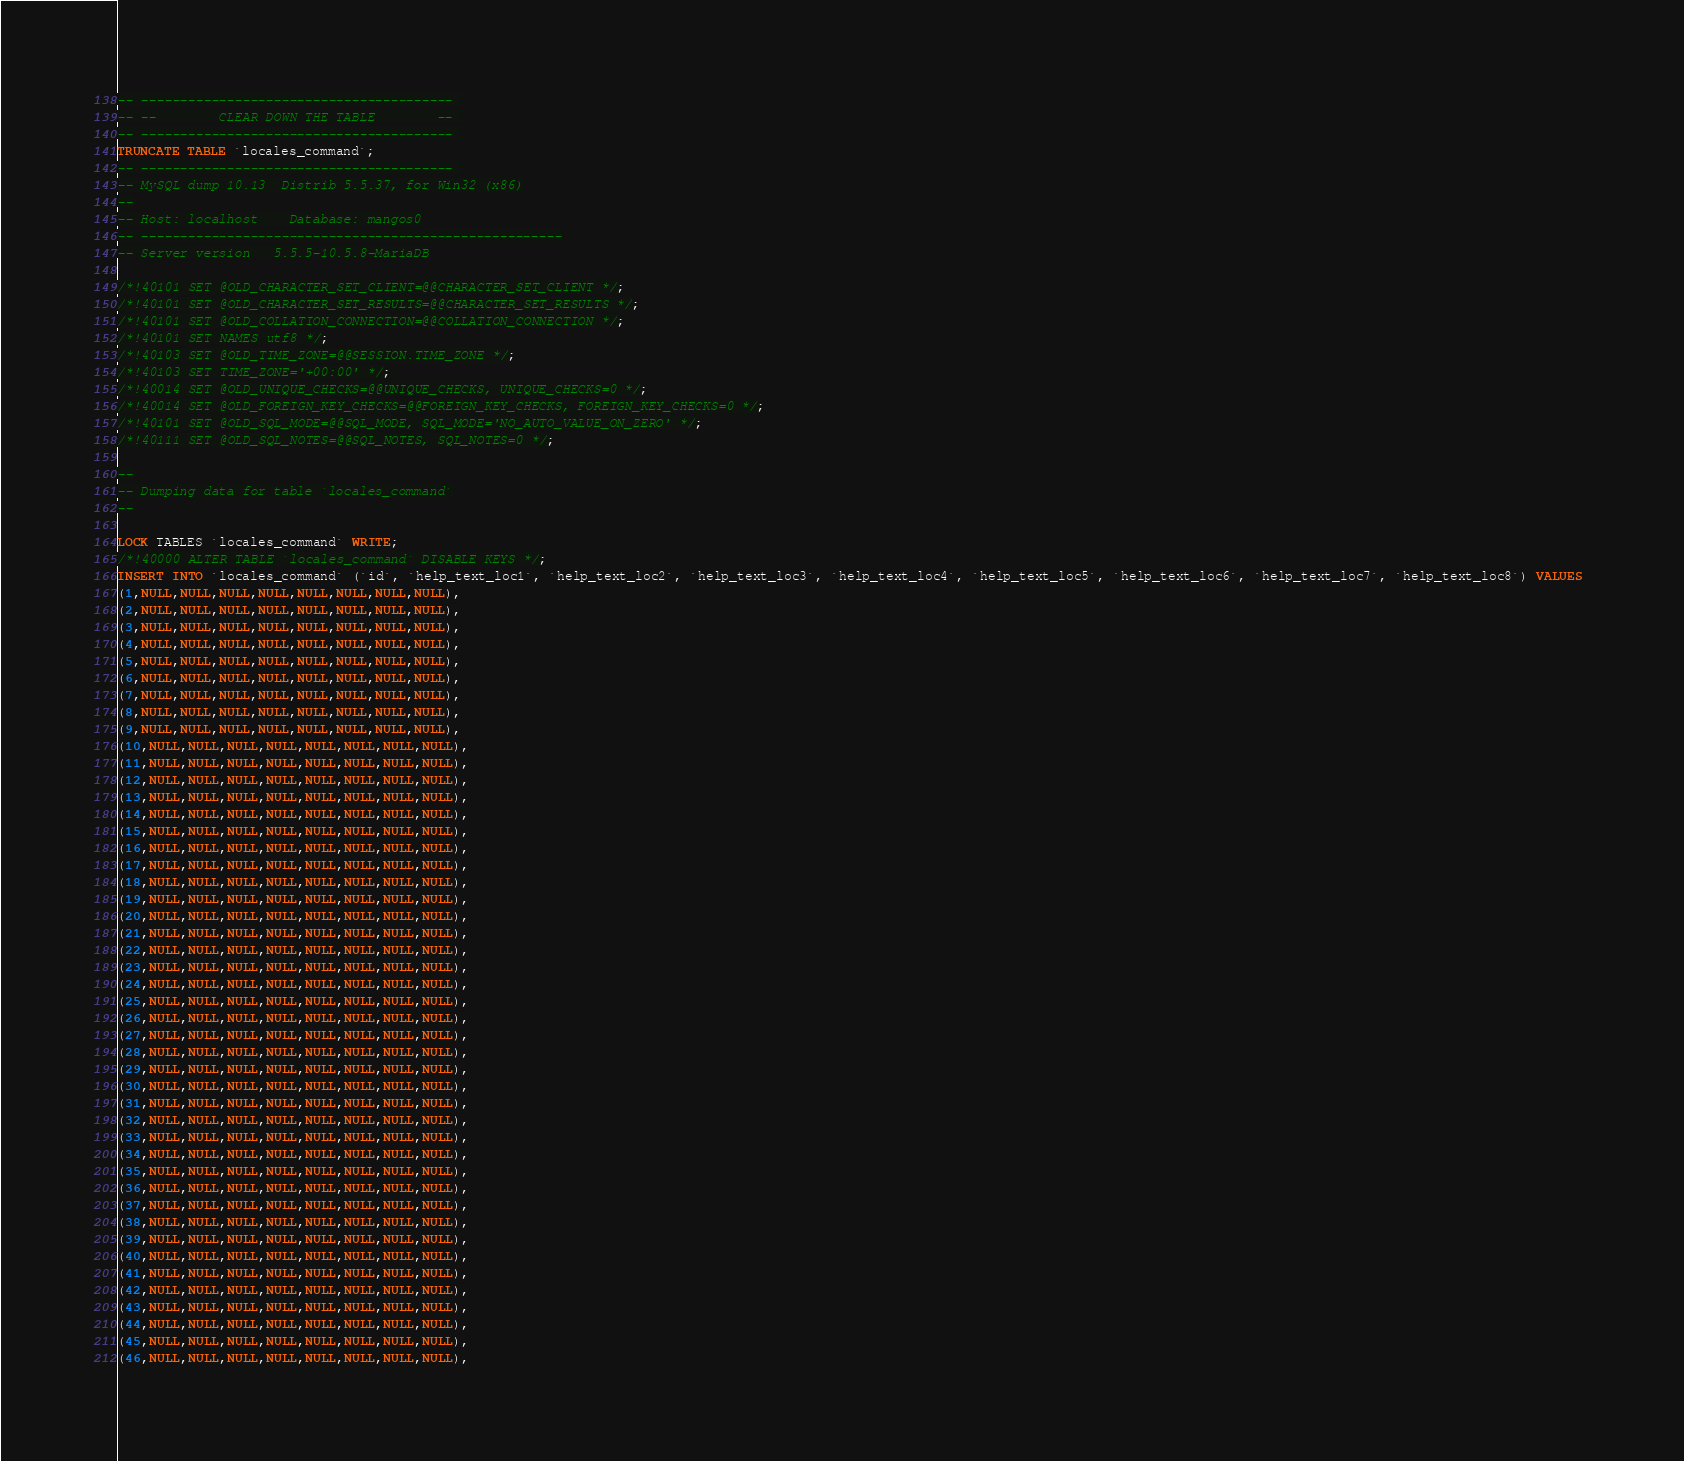<code> <loc_0><loc_0><loc_500><loc_500><_SQL_>-- ---------------------------------------- 
-- --        CLEAR DOWN THE TABLE        -- 
-- ---------------------------------------- 
TRUNCATE TABLE `locales_command`; 
-- ---------------------------------------- 
-- MySQL dump 10.13  Distrib 5.5.37, for Win32 (x86)
--
-- Host: localhost    Database: mangos0
-- ------------------------------------------------------
-- Server version	5.5.5-10.5.8-MariaDB

/*!40101 SET @OLD_CHARACTER_SET_CLIENT=@@CHARACTER_SET_CLIENT */;
/*!40101 SET @OLD_CHARACTER_SET_RESULTS=@@CHARACTER_SET_RESULTS */;
/*!40101 SET @OLD_COLLATION_CONNECTION=@@COLLATION_CONNECTION */;
/*!40101 SET NAMES utf8 */;
/*!40103 SET @OLD_TIME_ZONE=@@SESSION.TIME_ZONE */;
/*!40103 SET TIME_ZONE='+00:00' */;
/*!40014 SET @OLD_UNIQUE_CHECKS=@@UNIQUE_CHECKS, UNIQUE_CHECKS=0 */;
/*!40014 SET @OLD_FOREIGN_KEY_CHECKS=@@FOREIGN_KEY_CHECKS, FOREIGN_KEY_CHECKS=0 */;
/*!40101 SET @OLD_SQL_MODE=@@SQL_MODE, SQL_MODE='NO_AUTO_VALUE_ON_ZERO' */;
/*!40111 SET @OLD_SQL_NOTES=@@SQL_NOTES, SQL_NOTES=0 */;

--
-- Dumping data for table `locales_command`
--

LOCK TABLES `locales_command` WRITE;
/*!40000 ALTER TABLE `locales_command` DISABLE KEYS */;
INSERT INTO `locales_command` (`id`, `help_text_loc1`, `help_text_loc2`, `help_text_loc3`, `help_text_loc4`, `help_text_loc5`, `help_text_loc6`, `help_text_loc7`, `help_text_loc8`) VALUES 
(1,NULL,NULL,NULL,NULL,NULL,NULL,NULL,NULL),
(2,NULL,NULL,NULL,NULL,NULL,NULL,NULL,NULL),
(3,NULL,NULL,NULL,NULL,NULL,NULL,NULL,NULL),
(4,NULL,NULL,NULL,NULL,NULL,NULL,NULL,NULL),
(5,NULL,NULL,NULL,NULL,NULL,NULL,NULL,NULL),
(6,NULL,NULL,NULL,NULL,NULL,NULL,NULL,NULL),
(7,NULL,NULL,NULL,NULL,NULL,NULL,NULL,NULL),
(8,NULL,NULL,NULL,NULL,NULL,NULL,NULL,NULL),
(9,NULL,NULL,NULL,NULL,NULL,NULL,NULL,NULL),
(10,NULL,NULL,NULL,NULL,NULL,NULL,NULL,NULL),
(11,NULL,NULL,NULL,NULL,NULL,NULL,NULL,NULL),
(12,NULL,NULL,NULL,NULL,NULL,NULL,NULL,NULL),
(13,NULL,NULL,NULL,NULL,NULL,NULL,NULL,NULL),
(14,NULL,NULL,NULL,NULL,NULL,NULL,NULL,NULL),
(15,NULL,NULL,NULL,NULL,NULL,NULL,NULL,NULL),
(16,NULL,NULL,NULL,NULL,NULL,NULL,NULL,NULL),
(17,NULL,NULL,NULL,NULL,NULL,NULL,NULL,NULL),
(18,NULL,NULL,NULL,NULL,NULL,NULL,NULL,NULL),
(19,NULL,NULL,NULL,NULL,NULL,NULL,NULL,NULL),
(20,NULL,NULL,NULL,NULL,NULL,NULL,NULL,NULL),
(21,NULL,NULL,NULL,NULL,NULL,NULL,NULL,NULL),
(22,NULL,NULL,NULL,NULL,NULL,NULL,NULL,NULL),
(23,NULL,NULL,NULL,NULL,NULL,NULL,NULL,NULL),
(24,NULL,NULL,NULL,NULL,NULL,NULL,NULL,NULL),
(25,NULL,NULL,NULL,NULL,NULL,NULL,NULL,NULL),
(26,NULL,NULL,NULL,NULL,NULL,NULL,NULL,NULL),
(27,NULL,NULL,NULL,NULL,NULL,NULL,NULL,NULL),
(28,NULL,NULL,NULL,NULL,NULL,NULL,NULL,NULL),
(29,NULL,NULL,NULL,NULL,NULL,NULL,NULL,NULL),
(30,NULL,NULL,NULL,NULL,NULL,NULL,NULL,NULL),
(31,NULL,NULL,NULL,NULL,NULL,NULL,NULL,NULL),
(32,NULL,NULL,NULL,NULL,NULL,NULL,NULL,NULL),
(33,NULL,NULL,NULL,NULL,NULL,NULL,NULL,NULL),
(34,NULL,NULL,NULL,NULL,NULL,NULL,NULL,NULL),
(35,NULL,NULL,NULL,NULL,NULL,NULL,NULL,NULL),
(36,NULL,NULL,NULL,NULL,NULL,NULL,NULL,NULL),
(37,NULL,NULL,NULL,NULL,NULL,NULL,NULL,NULL),
(38,NULL,NULL,NULL,NULL,NULL,NULL,NULL,NULL),
(39,NULL,NULL,NULL,NULL,NULL,NULL,NULL,NULL),
(40,NULL,NULL,NULL,NULL,NULL,NULL,NULL,NULL),
(41,NULL,NULL,NULL,NULL,NULL,NULL,NULL,NULL),
(42,NULL,NULL,NULL,NULL,NULL,NULL,NULL,NULL),
(43,NULL,NULL,NULL,NULL,NULL,NULL,NULL,NULL),
(44,NULL,NULL,NULL,NULL,NULL,NULL,NULL,NULL),
(45,NULL,NULL,NULL,NULL,NULL,NULL,NULL,NULL),
(46,NULL,NULL,NULL,NULL,NULL,NULL,NULL,NULL),</code> 